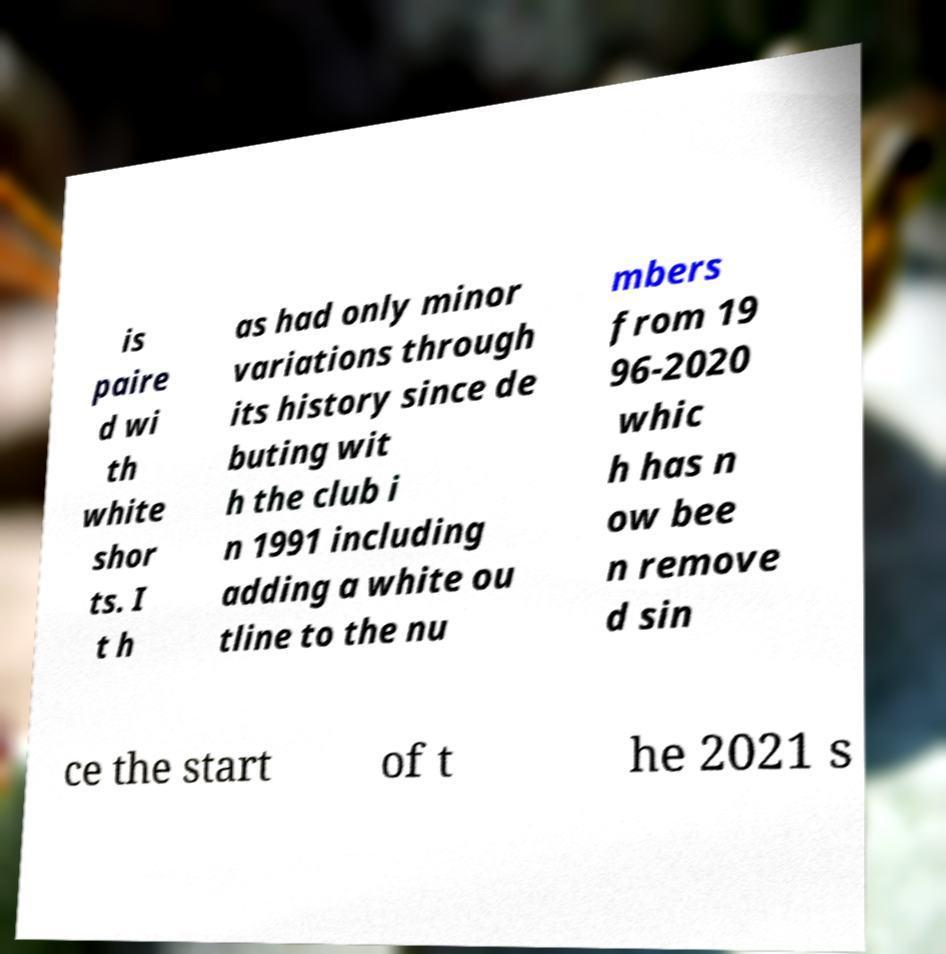Can you read and provide the text displayed in the image?This photo seems to have some interesting text. Can you extract and type it out for me? is paire d wi th white shor ts. I t h as had only minor variations through its history since de buting wit h the club i n 1991 including adding a white ou tline to the nu mbers from 19 96-2020 whic h has n ow bee n remove d sin ce the start of t he 2021 s 